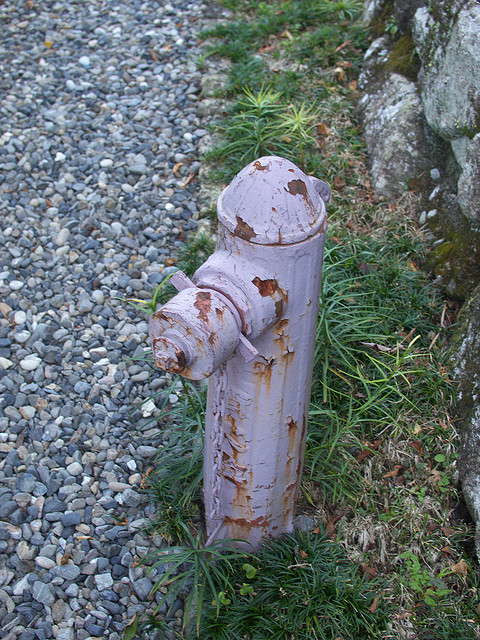What kind of environment is the fireplug located in? The fireplug appears to be located in an outdoor, possibly urban or semi-urban environment. The presence of small gray pebbles suggests it could be part of a landscaped area, while the surrounding greenery, including grass and weeds, indicates it is not a heavily trafficked spot. The rock or wall seen in the image might belong to a nearby structure or border. 